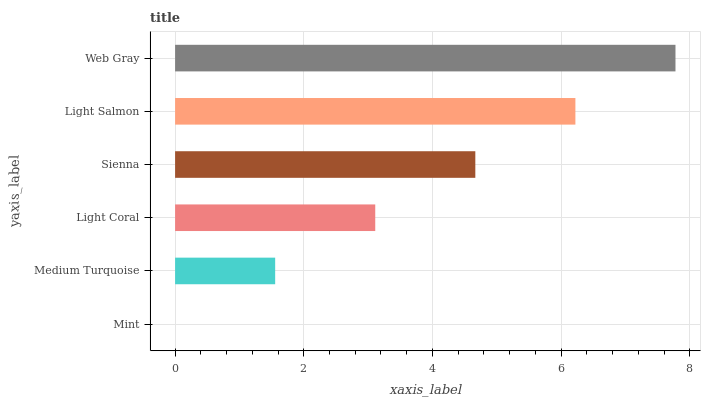Is Mint the minimum?
Answer yes or no. Yes. Is Web Gray the maximum?
Answer yes or no. Yes. Is Medium Turquoise the minimum?
Answer yes or no. No. Is Medium Turquoise the maximum?
Answer yes or no. No. Is Medium Turquoise greater than Mint?
Answer yes or no. Yes. Is Mint less than Medium Turquoise?
Answer yes or no. Yes. Is Mint greater than Medium Turquoise?
Answer yes or no. No. Is Medium Turquoise less than Mint?
Answer yes or no. No. Is Sienna the high median?
Answer yes or no. Yes. Is Light Coral the low median?
Answer yes or no. Yes. Is Light Coral the high median?
Answer yes or no. No. Is Web Gray the low median?
Answer yes or no. No. 